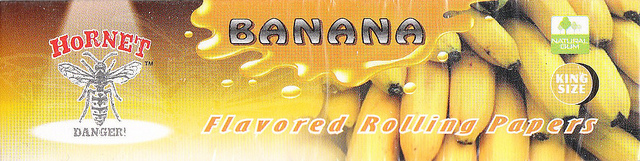Read and extract the text from this image. BANANA Flavored Rolling papers DANGER! TM GUM NATURAL SIZE KING HORNET 